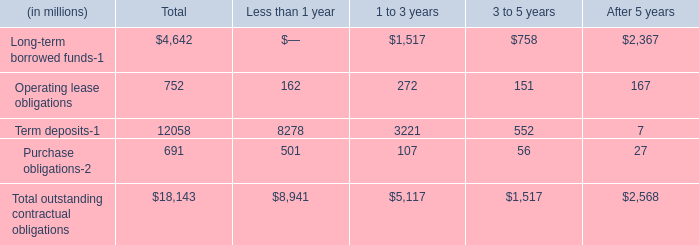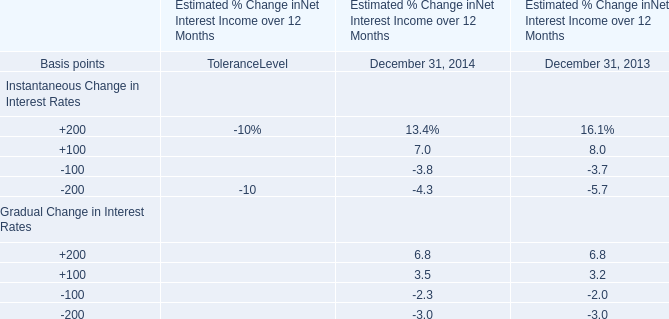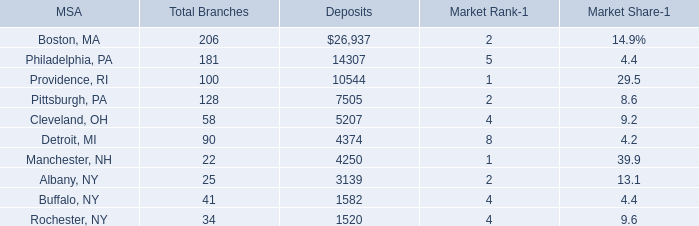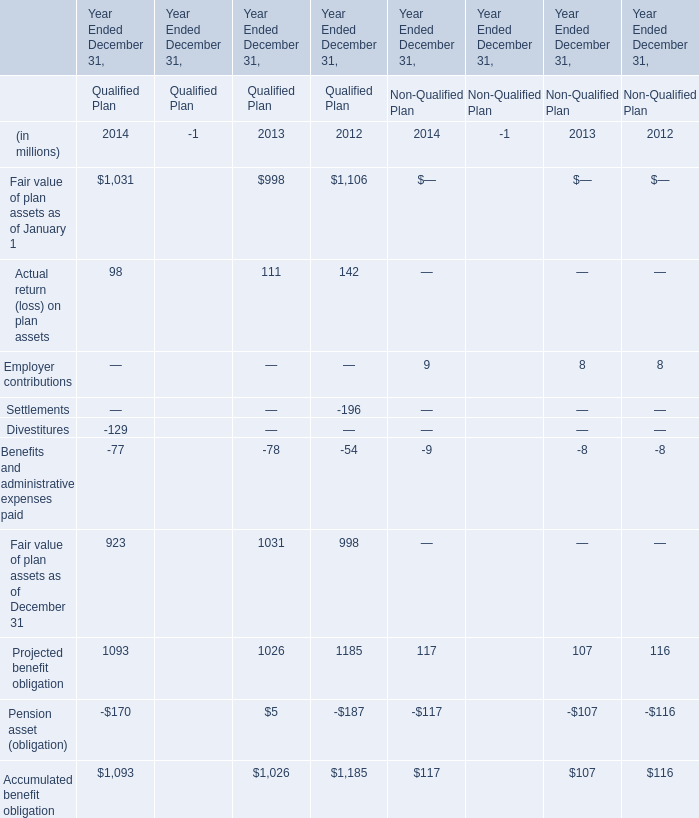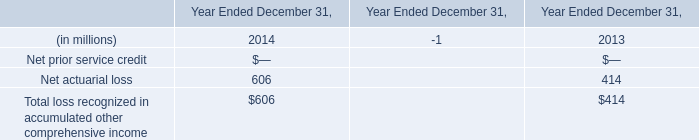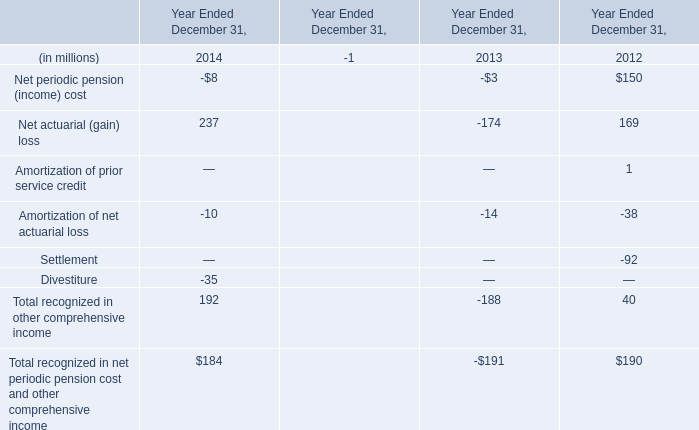What's the average of Term deposits of Less than 1 year, and Boston, MA of Deposits ? 
Computations: ((8278.0 + 26937.0) / 2)
Answer: 17607.5. 